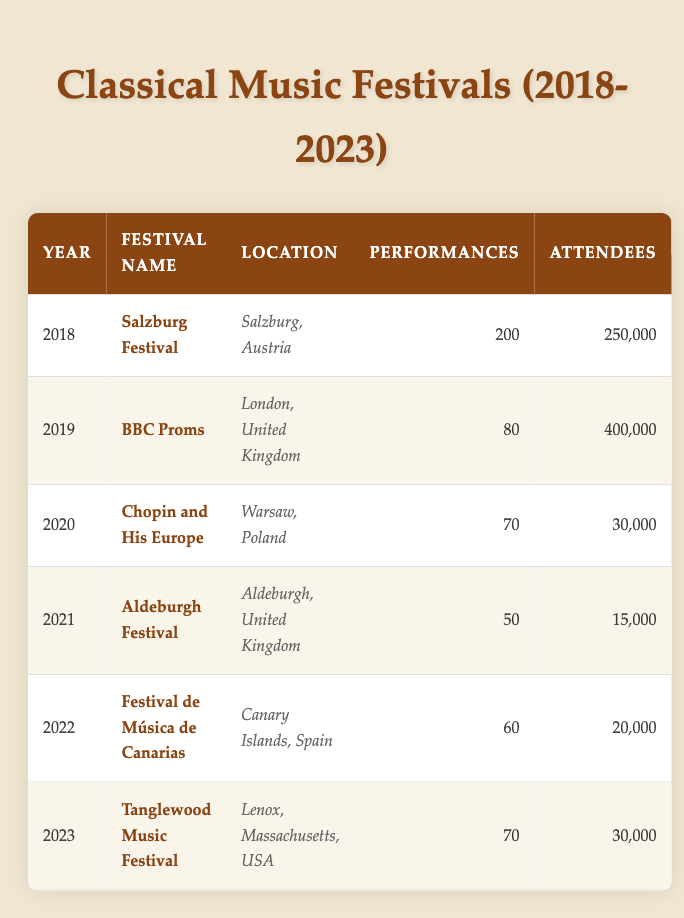What was the highest number of attendees at a classical music festival from 2018 to 2023? In 2019, the BBC Proms had the highest number of attendees, which is 400,000. This can be seen by comparing the attendee numbers of all listed festivals across the years.
Answer: 400,000 Which festival in 2020 had the least number of performances? The festival in 2020, "Chopin and His Europe," had the least number of performances, which was 70. When looking at the number of performances for each festival, this is the lowest value.
Answer: 70 Did the number of attendees increase from 2021 to 2022? From 2021 (Aldeburgh Festival, 15,000 attendees) to 2022 (Festival de Música de Canarias, 20,000 attendees), the number of attendees did increase. This can be verified by comparing the attendee numbers year on year.
Answer: Yes What is the total number of performances across all festivals from 2018 to 2023? To find the total, we sum the performances: 200 + 80 + 70 + 50 + 60 + 70 = 530. Each row in the table contains the number of performances, and adding them gives the total.
Answer: 530 Which festival had the highest number of performances, and in what year was it held? The festival with the highest number of performances was the Salzburg Festival in 2018 with 200 performances. By looking at the performances listed for each festival, this is the highest number found.
Answer: Salzburg Festival, 2018 What was the average number of attendees for classical music festivals from 2018 to 2023? To calculate the average, we sum the attendees: 250,000 + 400,000 + 30,000 + 15,000 + 20,000 + 30,000 = 745,000 attendees. Then, divide by the number of festivals (6): 745,000 / 6 = approximately 124,167. This gives the average number of attendees across festivals.
Answer: Approximately 124,167 Was there any year when fewer than 60 performances were held? Yes, in both 2021 (50 performances) and 2022 (60 performances), there were years when fewer than 60 performances were held. This can be confirmed by checking the number of performances for each year.
Answer: Yes 